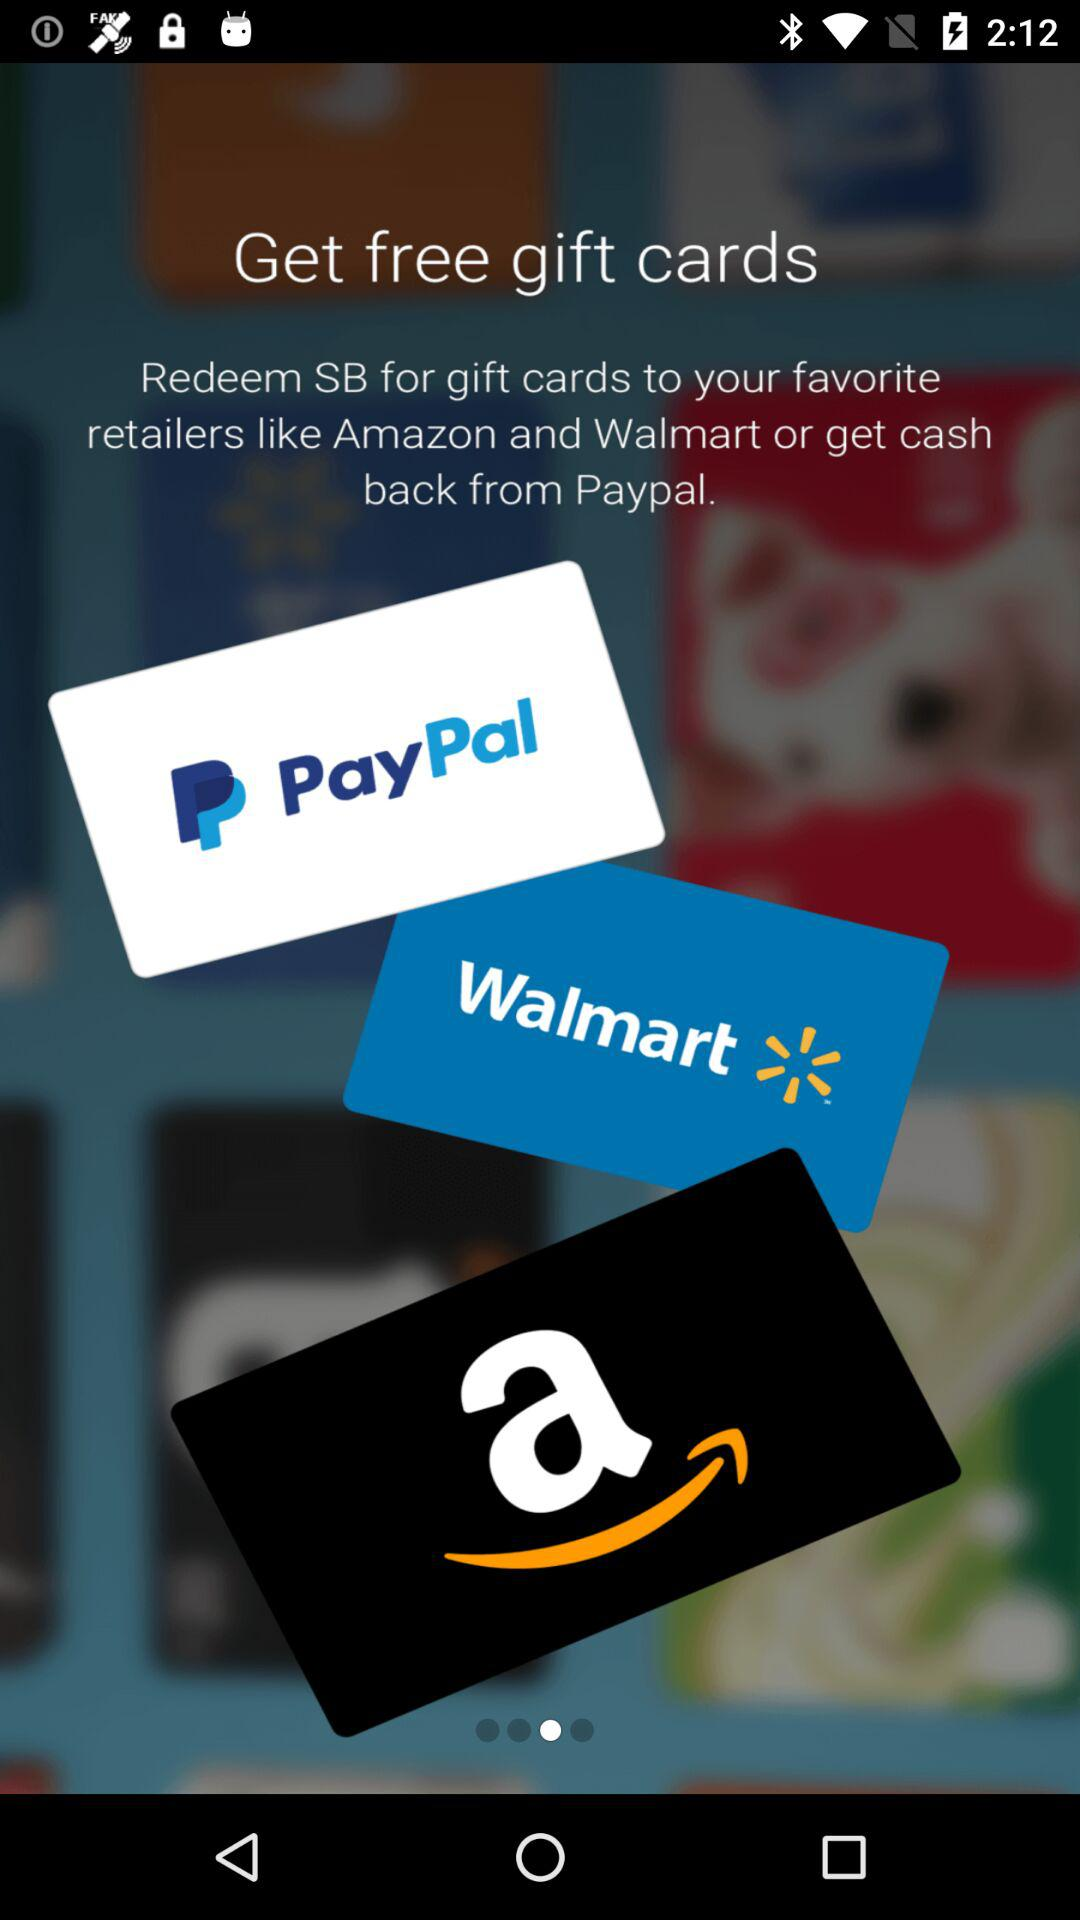How many retailers are mentioned in the text?
Answer the question using a single word or phrase. 2 